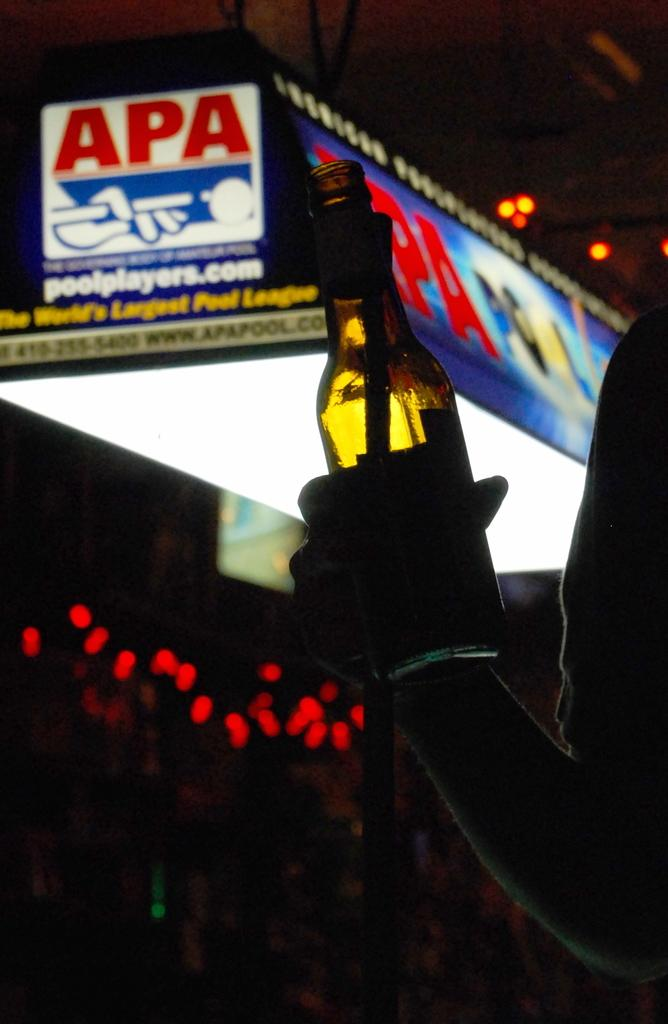Provide a one-sentence caption for the provided image. The website advertised is pool players dot com. 